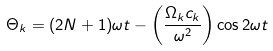<formula> <loc_0><loc_0><loc_500><loc_500>\Theta _ { k } = ( 2 N + 1 ) \omega t - \left ( \frac { \Omega _ { k } c _ { k } } { \omega ^ { 2 } } \right ) \cos 2 \omega t</formula> 